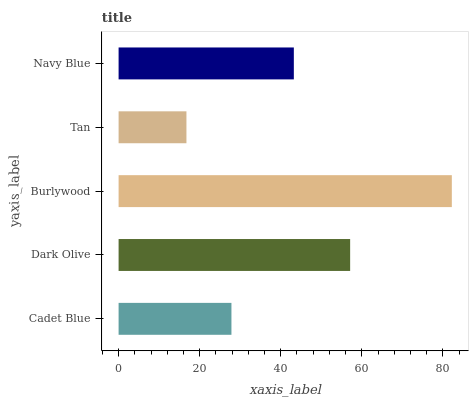Is Tan the minimum?
Answer yes or no. Yes. Is Burlywood the maximum?
Answer yes or no. Yes. Is Dark Olive the minimum?
Answer yes or no. No. Is Dark Olive the maximum?
Answer yes or no. No. Is Dark Olive greater than Cadet Blue?
Answer yes or no. Yes. Is Cadet Blue less than Dark Olive?
Answer yes or no. Yes. Is Cadet Blue greater than Dark Olive?
Answer yes or no. No. Is Dark Olive less than Cadet Blue?
Answer yes or no. No. Is Navy Blue the high median?
Answer yes or no. Yes. Is Navy Blue the low median?
Answer yes or no. Yes. Is Dark Olive the high median?
Answer yes or no. No. Is Dark Olive the low median?
Answer yes or no. No. 